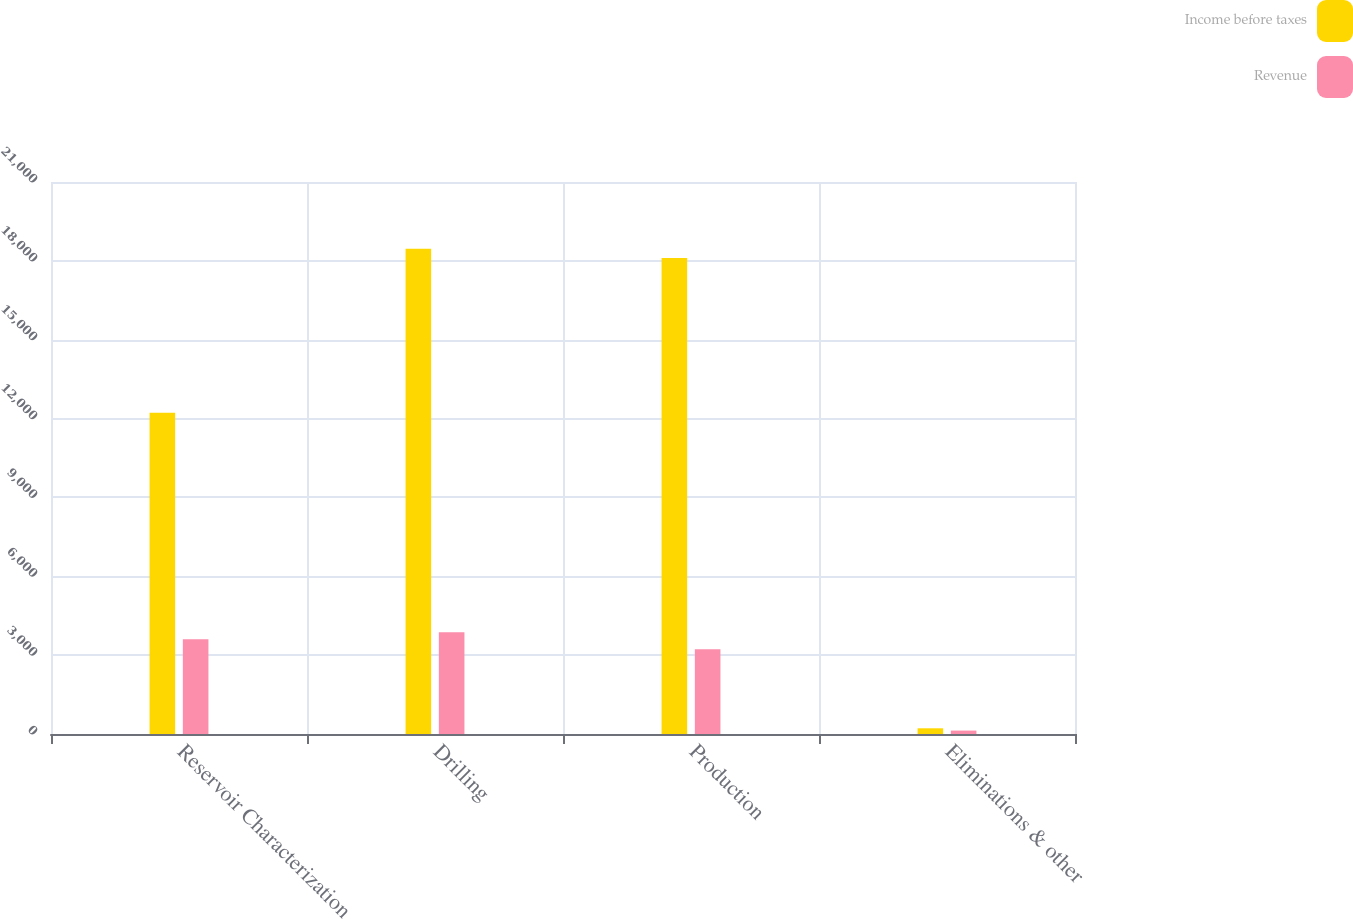Convert chart. <chart><loc_0><loc_0><loc_500><loc_500><stacked_bar_chart><ecel><fcel>Reservoir Characterization<fcel>Drilling<fcel>Production<fcel>Eliminations & other<nl><fcel>Income before taxes<fcel>12224<fcel>18462<fcel>18111<fcel>217<nl><fcel>Revenue<fcel>3607<fcel>3872<fcel>3227<fcel>130<nl></chart> 